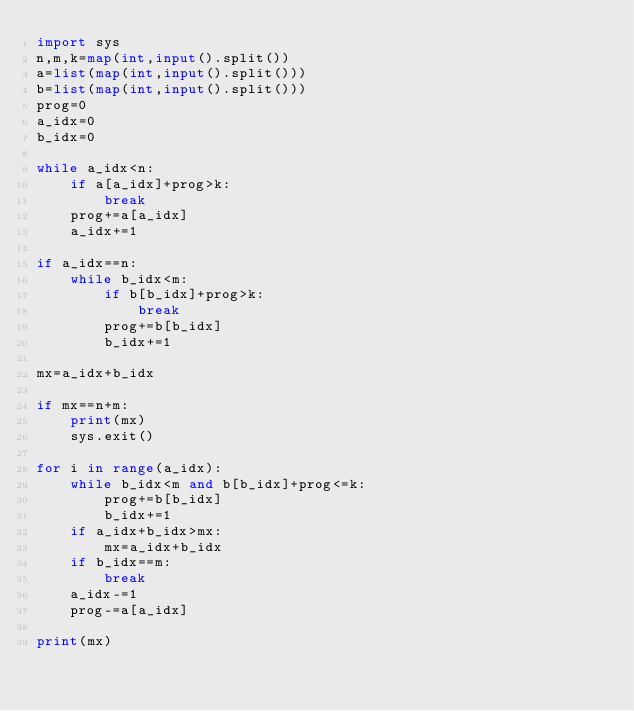<code> <loc_0><loc_0><loc_500><loc_500><_Python_>import sys
n,m,k=map(int,input().split())
a=list(map(int,input().split()))
b=list(map(int,input().split()))
prog=0
a_idx=0
b_idx=0

while a_idx<n:
    if a[a_idx]+prog>k:
        break
    prog+=a[a_idx]
    a_idx+=1

if a_idx==n:
    while b_idx<m:
        if b[b_idx]+prog>k:
            break
        prog+=b[b_idx]
        b_idx+=1

mx=a_idx+b_idx

if mx==n+m:
    print(mx)
    sys.exit()

for i in range(a_idx):
    while b_idx<m and b[b_idx]+prog<=k:
        prog+=b[b_idx]
        b_idx+=1
    if a_idx+b_idx>mx:
        mx=a_idx+b_idx
    if b_idx==m:
        break
    a_idx-=1
    prog-=a[a_idx]

print(mx)</code> 